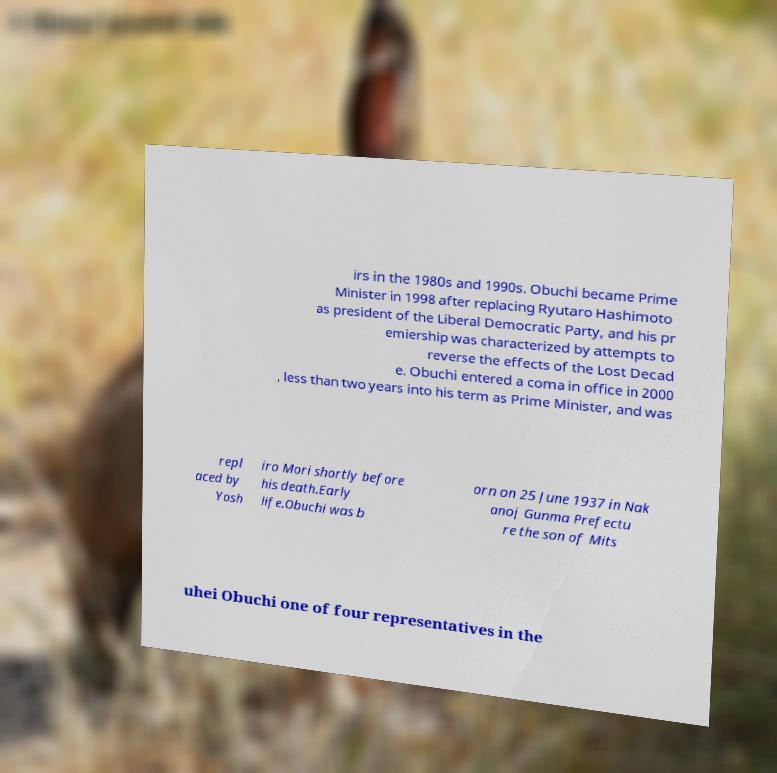Can you read and provide the text displayed in the image?This photo seems to have some interesting text. Can you extract and type it out for me? irs in the 1980s and 1990s. Obuchi became Prime Minister in 1998 after replacing Ryutaro Hashimoto as president of the Liberal Democratic Party, and his pr emiership was characterized by attempts to reverse the effects of the Lost Decad e. Obuchi entered a coma in office in 2000 , less than two years into his term as Prime Minister, and was repl aced by Yosh iro Mori shortly before his death.Early life.Obuchi was b orn on 25 June 1937 in Nak anoj Gunma Prefectu re the son of Mits uhei Obuchi one of four representatives in the 